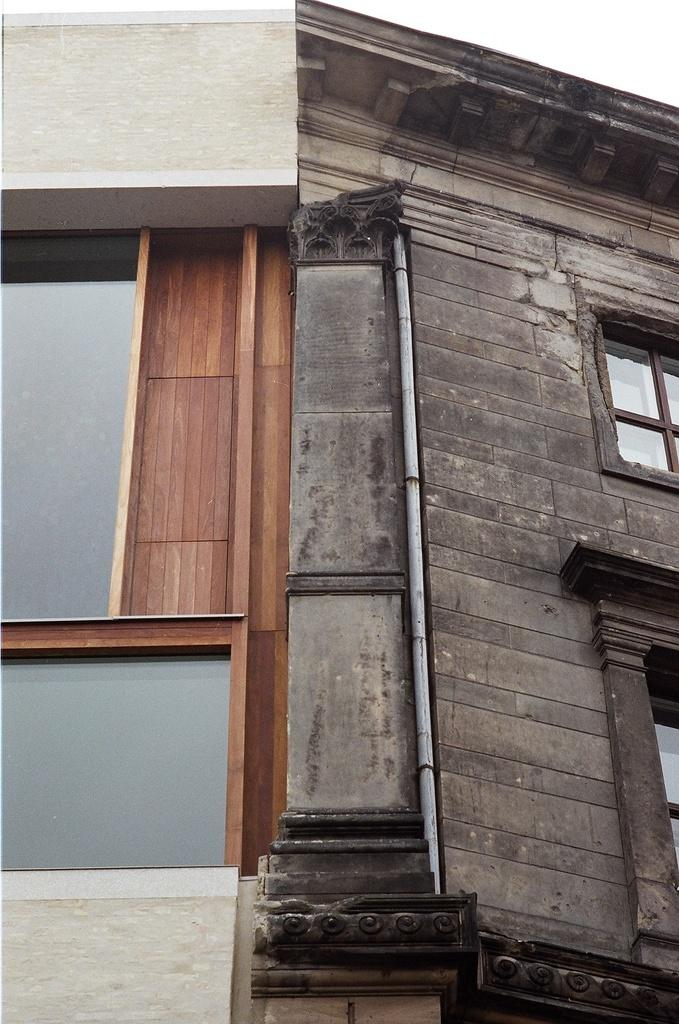What is the main structure in the image? There is a building in the image. What feature can be seen on the building? The building has windows. What else is visible in the image besides the building? The sky is visible in the image. How many haircuts can be seen happening in the image? There are no haircuts visible in the image; it features a building with windows and a visible sky. 